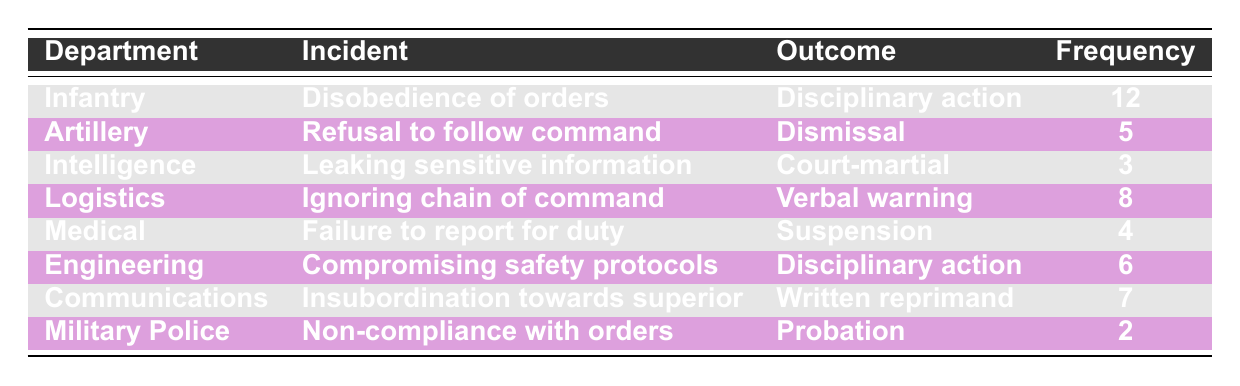What is the total frequency of insubordination incidents reported by the Infantry department? The Infantry department has one incident listed with a frequency of 12. Therefore, the total frequency is simply 12.
Answer: 12 Which department reported the highest frequency of incidents of insubordination? By reviewing the frequencies in the table, the Infantry department has the highest frequency reported at 12, while other departments report lower frequencies.
Answer: Infantry Is there a department that reported no incidents of insubordination? The table lists frequencies for all departments; hence, none report zero incidents. Therefore, the answer is no.
Answer: No What is the average frequency of reported insubordination incidents across all departments? By adding all the frequencies (12 + 5 + 3 + 8 + 4 + 6 + 7 + 2 = 47) and dividing by the number of departments (8), we calculate an average of 47/8 = 5.875.
Answer: 5.875 How many total incidents resulted in disciplinary action across all departments? The total incidents that resulted in disciplinary action can be summed: 12 (Infantry) + 6 (Engineering) = 18; therefore, the total is 18 disciplinary actions recorded.
Answer: 18 Is it true that all departments reported at least one incident of disobedience? The table shows several departments and their incidents; however, there is no indication that every department recorded disobedience. The Military Police, for instance, reported 'Non-compliance', not 'disobedience'. Thus, it is false.
Answer: No How many more incidents of insubordination were reported in Logistics compared to Medical? The Logistics department reported 8 incidents while Medical reported 4. The difference is 8 - 4 = 4 incidents.
Answer: 4 If we consider only the incidents that resulted in a court-martial or dismissal, what is the total frequency? Only two outcomes fall into this category: 3 from Intelligence (court-martial) and 5 from Artillery (dismissal). Thus, the total is 3 + 5 = 8.
Answer: 8 